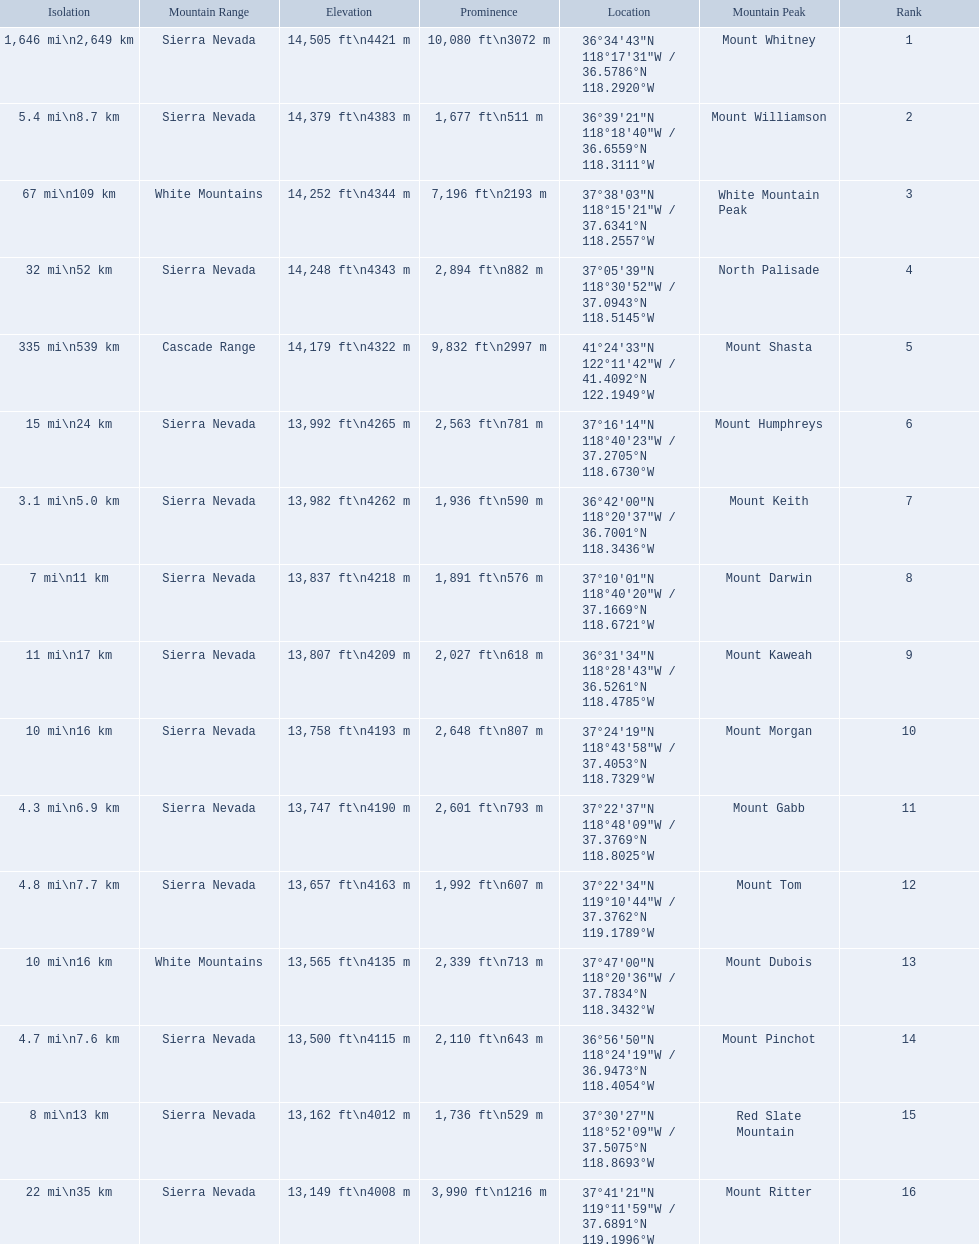What are the heights of the californian mountain peaks? 14,505 ft\n4421 m, 14,379 ft\n4383 m, 14,252 ft\n4344 m, 14,248 ft\n4343 m, 14,179 ft\n4322 m, 13,992 ft\n4265 m, 13,982 ft\n4262 m, 13,837 ft\n4218 m, 13,807 ft\n4209 m, 13,758 ft\n4193 m, 13,747 ft\n4190 m, 13,657 ft\n4163 m, 13,565 ft\n4135 m, 13,500 ft\n4115 m, 13,162 ft\n4012 m, 13,149 ft\n4008 m. What elevation is 13,149 ft or less? 13,149 ft\n4008 m. What mountain peak is at this elevation? Mount Ritter. 